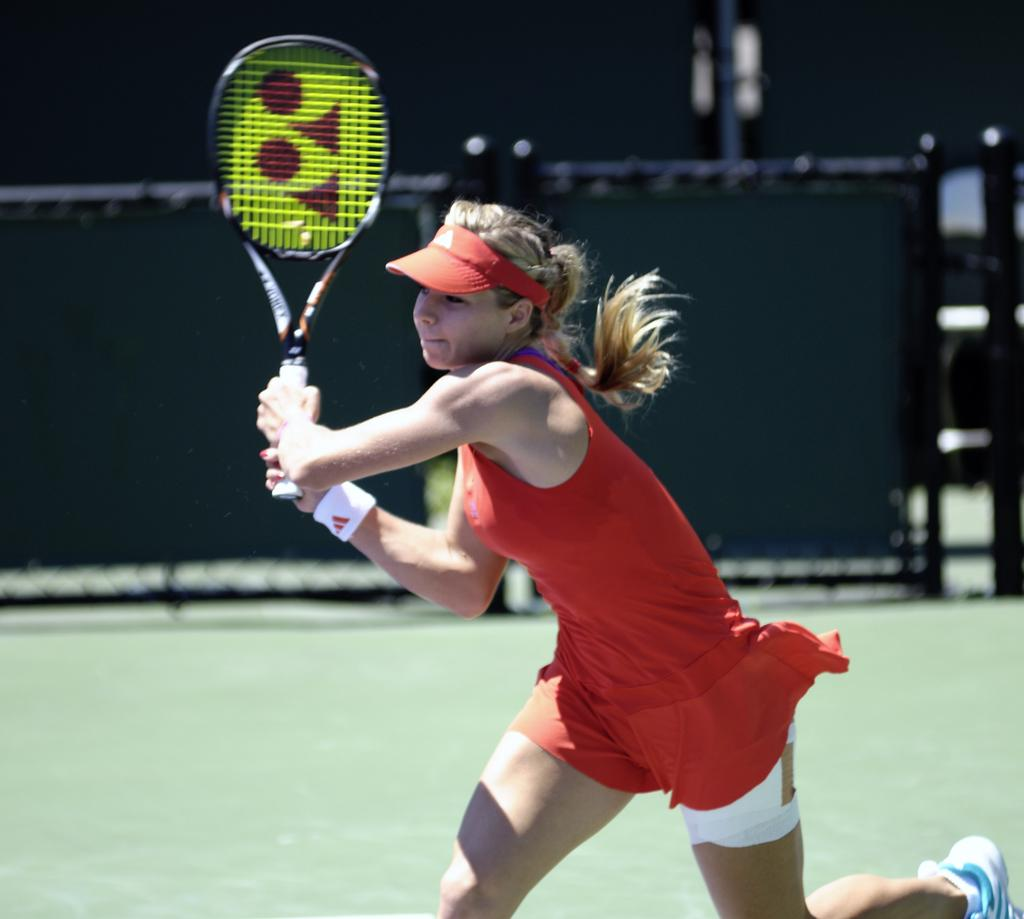Who is present in the image? There is a woman in the image. What is the woman holding in her hands? The woman is holding a racket in her hands. What can be seen beneath the woman's feet in the image? The ground is visible in the image. What type of brush is the woman using to paint the berries in the image? There is no brush or berries present in the image; the woman is holding a racket. Is the woman wearing a hat in the image? There is no hat visible in the image; the woman's head is not shown. 